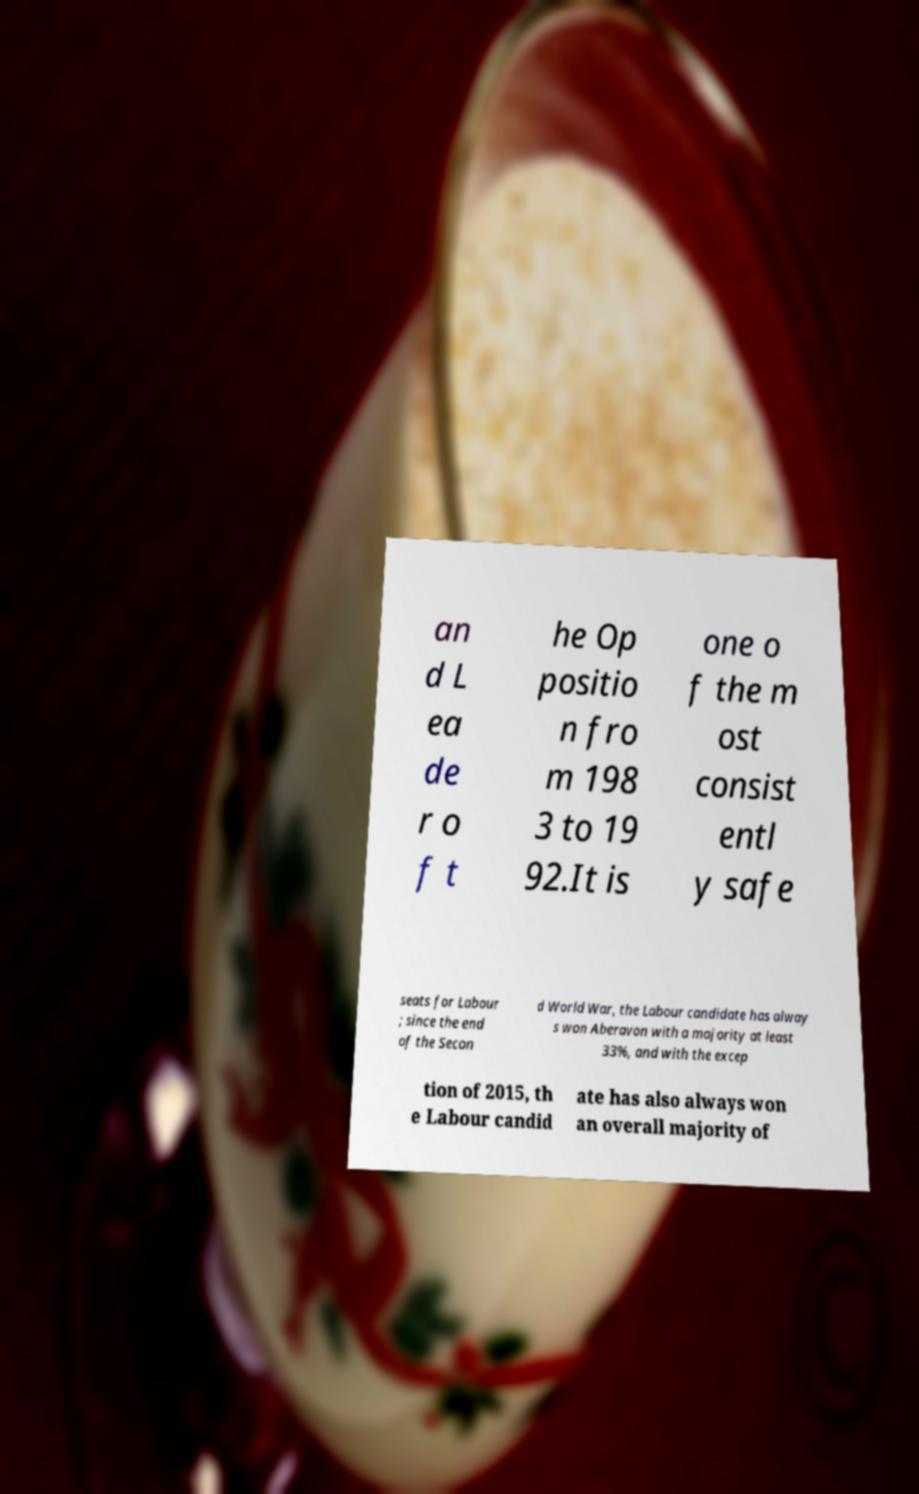Please read and relay the text visible in this image. What does it say? an d L ea de r o f t he Op positio n fro m 198 3 to 19 92.It is one o f the m ost consist entl y safe seats for Labour ; since the end of the Secon d World War, the Labour candidate has alway s won Aberavon with a majority at least 33%, and with the excep tion of 2015, th e Labour candid ate has also always won an overall majority of 